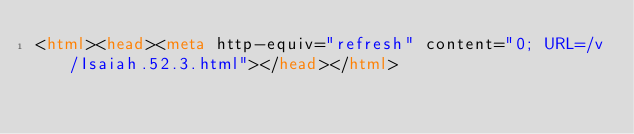Convert code to text. <code><loc_0><loc_0><loc_500><loc_500><_HTML_><html><head><meta http-equiv="refresh" content="0; URL=/v/Isaiah.52.3.html"></head></html></code> 